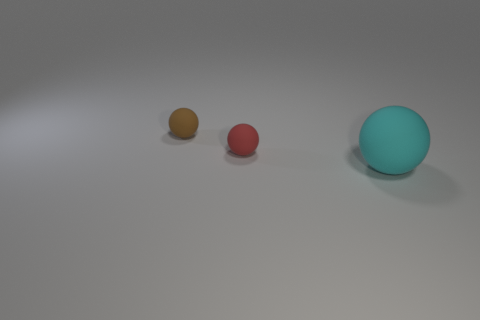How many small things are gray metallic spheres or cyan spheres?
Offer a very short reply. 0. Is there anything else that has the same size as the brown thing?
Provide a succinct answer. Yes. What material is the tiny ball in front of the small ball that is behind the red ball?
Offer a very short reply. Rubber. Is the size of the brown matte ball the same as the cyan matte sphere?
Your answer should be very brief. No. How many objects are either balls to the right of the small brown ball or large purple cylinders?
Ensure brevity in your answer.  2. Do the cyan matte sphere and the ball behind the small red sphere have the same size?
Offer a very short reply. No. What is the material of the small sphere that is behind the tiny red rubber ball?
Your answer should be compact. Rubber. What number of matte objects are both on the left side of the cyan ball and in front of the small brown sphere?
Ensure brevity in your answer.  1. There is a red sphere that is the same size as the brown object; what material is it?
Provide a short and direct response. Rubber. There is a rubber thing right of the red matte thing; is its size the same as the sphere to the left of the tiny red object?
Offer a very short reply. No. 